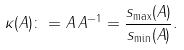Convert formula to latex. <formula><loc_0><loc_0><loc_500><loc_500>\kappa ( A ) \colon = \| A \| \, \| A ^ { - 1 } \| = \frac { s _ { \max } ( A ) } { s _ { \min } ( A ) } .</formula> 